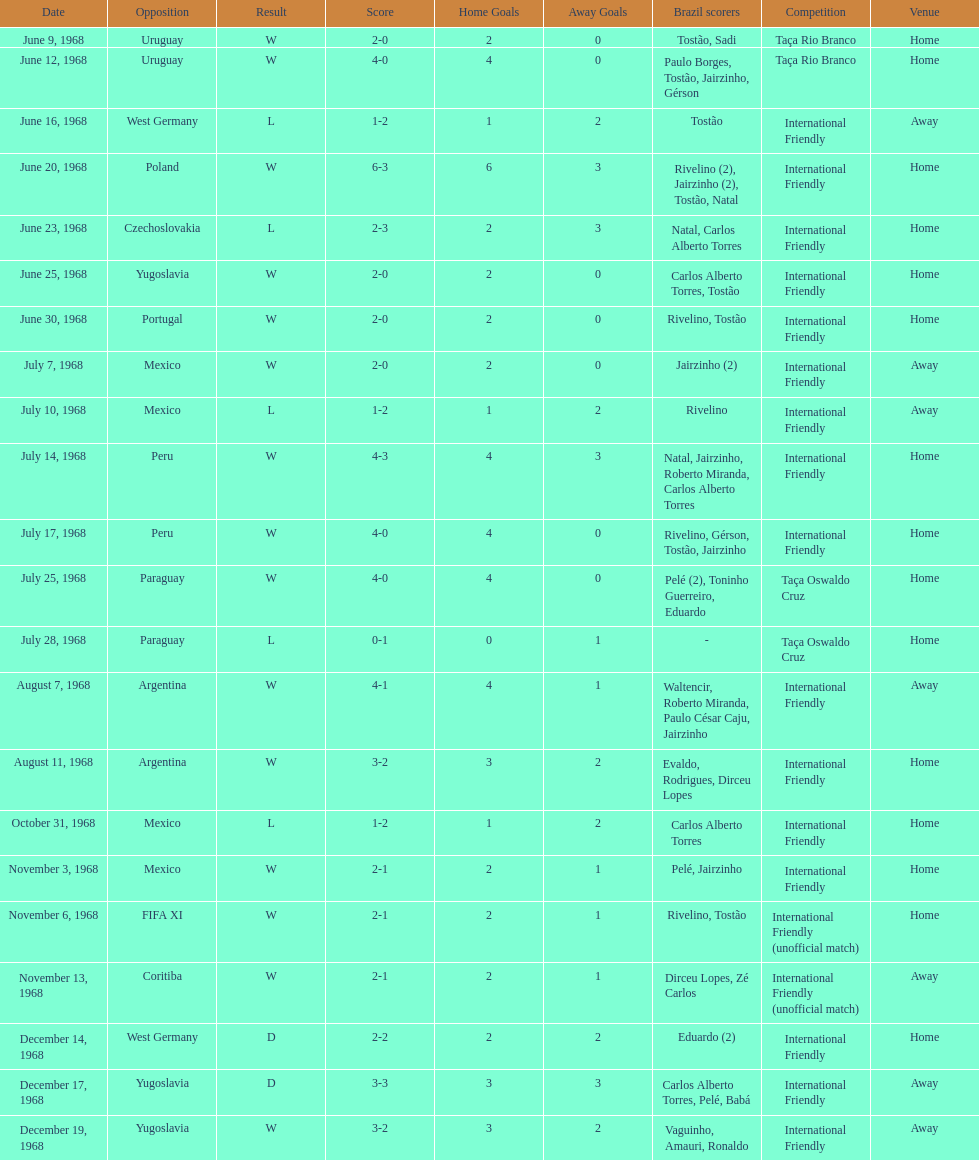Number of losses 5. 